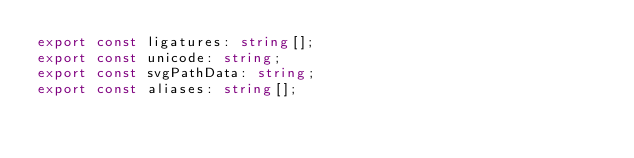<code> <loc_0><loc_0><loc_500><loc_500><_TypeScript_>export const ligatures: string[];
export const unicode: string;
export const svgPathData: string;
export const aliases: string[];</code> 